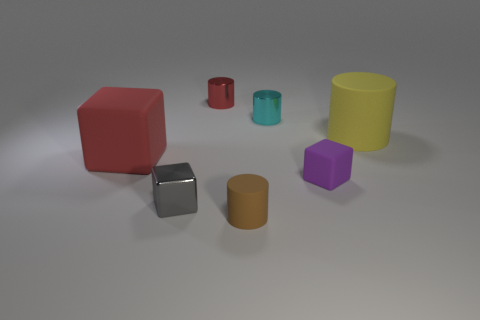Subtract all matte blocks. How many blocks are left? 1 Add 2 tiny matte objects. How many objects exist? 9 Subtract all red blocks. How many blocks are left? 2 Add 5 rubber blocks. How many rubber blocks are left? 7 Add 5 big yellow metal cylinders. How many big yellow metal cylinders exist? 5 Subtract 0 yellow blocks. How many objects are left? 7 Subtract all cubes. How many objects are left? 4 Subtract 3 cylinders. How many cylinders are left? 1 Subtract all brown cubes. Subtract all blue cylinders. How many cubes are left? 3 Subtract all red spheres. How many red cylinders are left? 1 